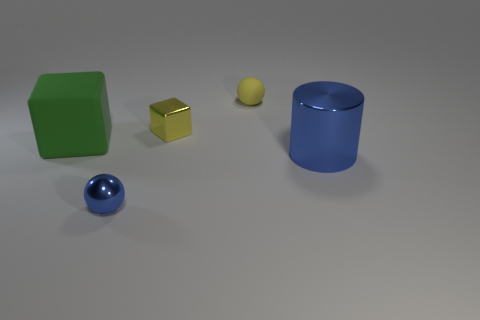Can you describe the color of the object at the far right? The object at the far right is a cylinder, and it has a vibrant blue color with a glossy finish that reflects the light, giving it a shiny appearance. What does the reflection on the blue cylinder tell us about the environment? The reflection on the blue cylinder suggests that the environment has a uniform light source that creates a soft shadow under the cylinder. The uniformity and softness of the shadows indicate a diffuse light source, which might be present in a controlled indoor setting, such as a photography studio or a rendering in a 3D modeled scene. 